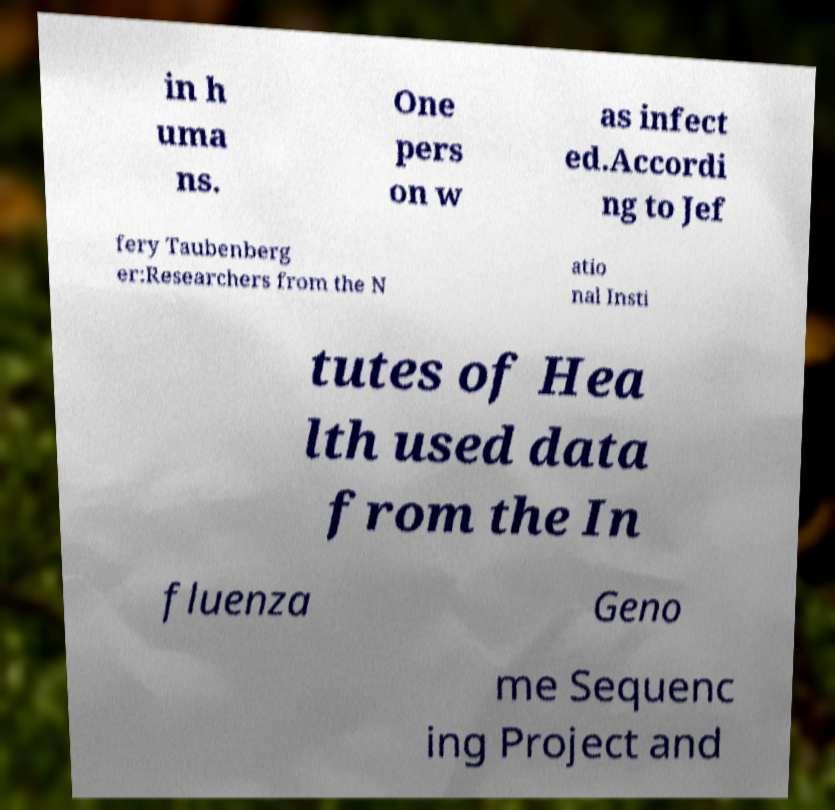For documentation purposes, I need the text within this image transcribed. Could you provide that? in h uma ns. One pers on w as infect ed.Accordi ng to Jef fery Taubenberg er:Researchers from the N atio nal Insti tutes of Hea lth used data from the In fluenza Geno me Sequenc ing Project and 